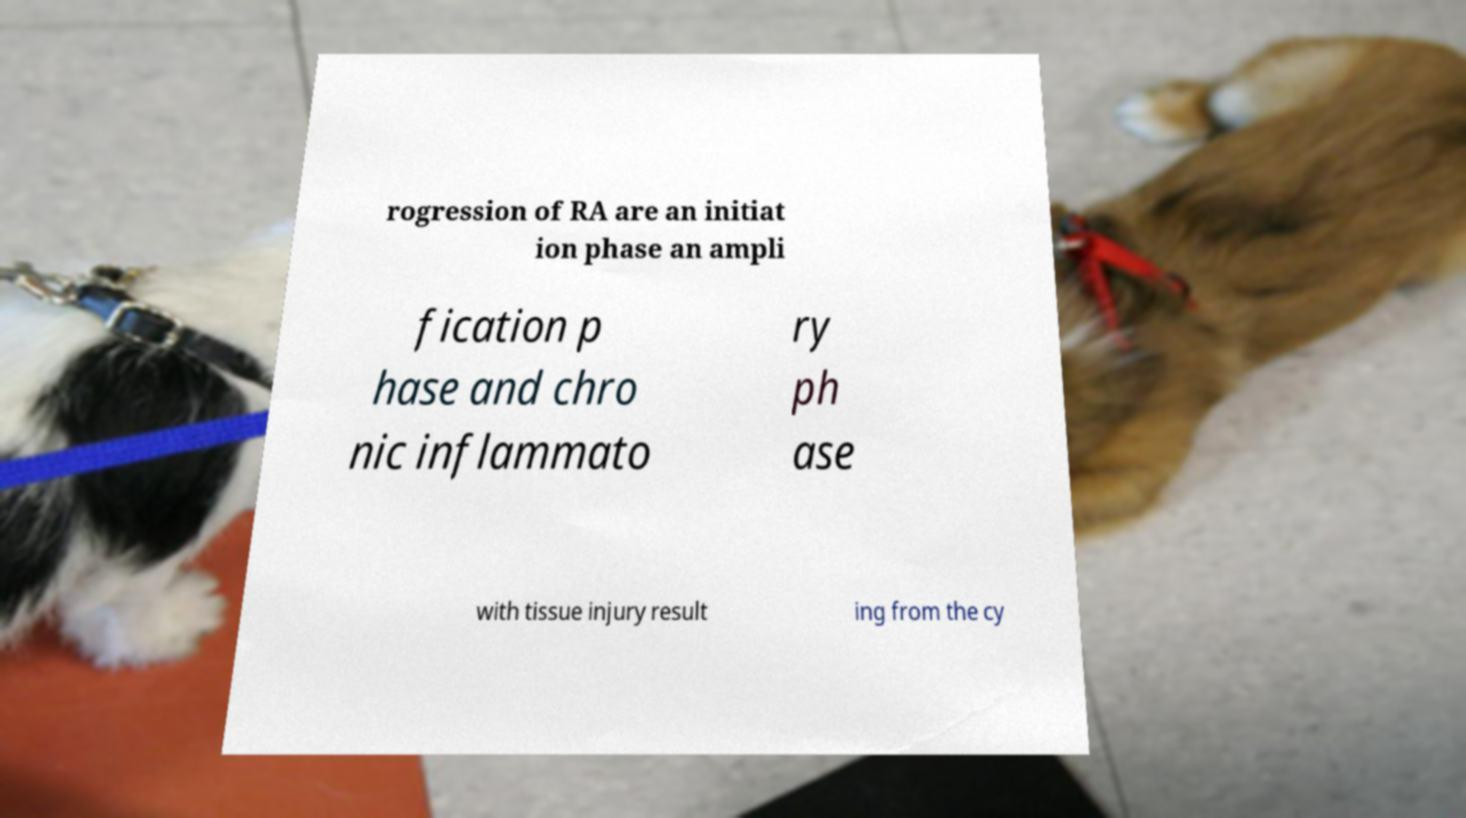Could you extract and type out the text from this image? rogression of RA are an initiat ion phase an ampli fication p hase and chro nic inflammato ry ph ase with tissue injury result ing from the cy 